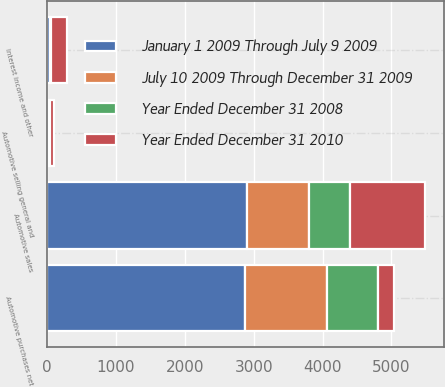Convert chart to OTSL. <chart><loc_0><loc_0><loc_500><loc_500><stacked_bar_chart><ecel><fcel>Automotive sales<fcel>Automotive purchases net<fcel>Automotive selling general and<fcel>Interest income and other<nl><fcel>January 1 2009 Through July 9 2009<fcel>2910<fcel>2881<fcel>3<fcel>43<nl><fcel>July 10 2009 Through December 31 2009<fcel>899<fcel>1190<fcel>19<fcel>14<nl><fcel>Year Ended December 31 2008<fcel>596<fcel>737<fcel>19<fcel>9<nl><fcel>Year Ended December 31 2010<fcel>1076<fcel>231<fcel>62<fcel>231<nl></chart> 